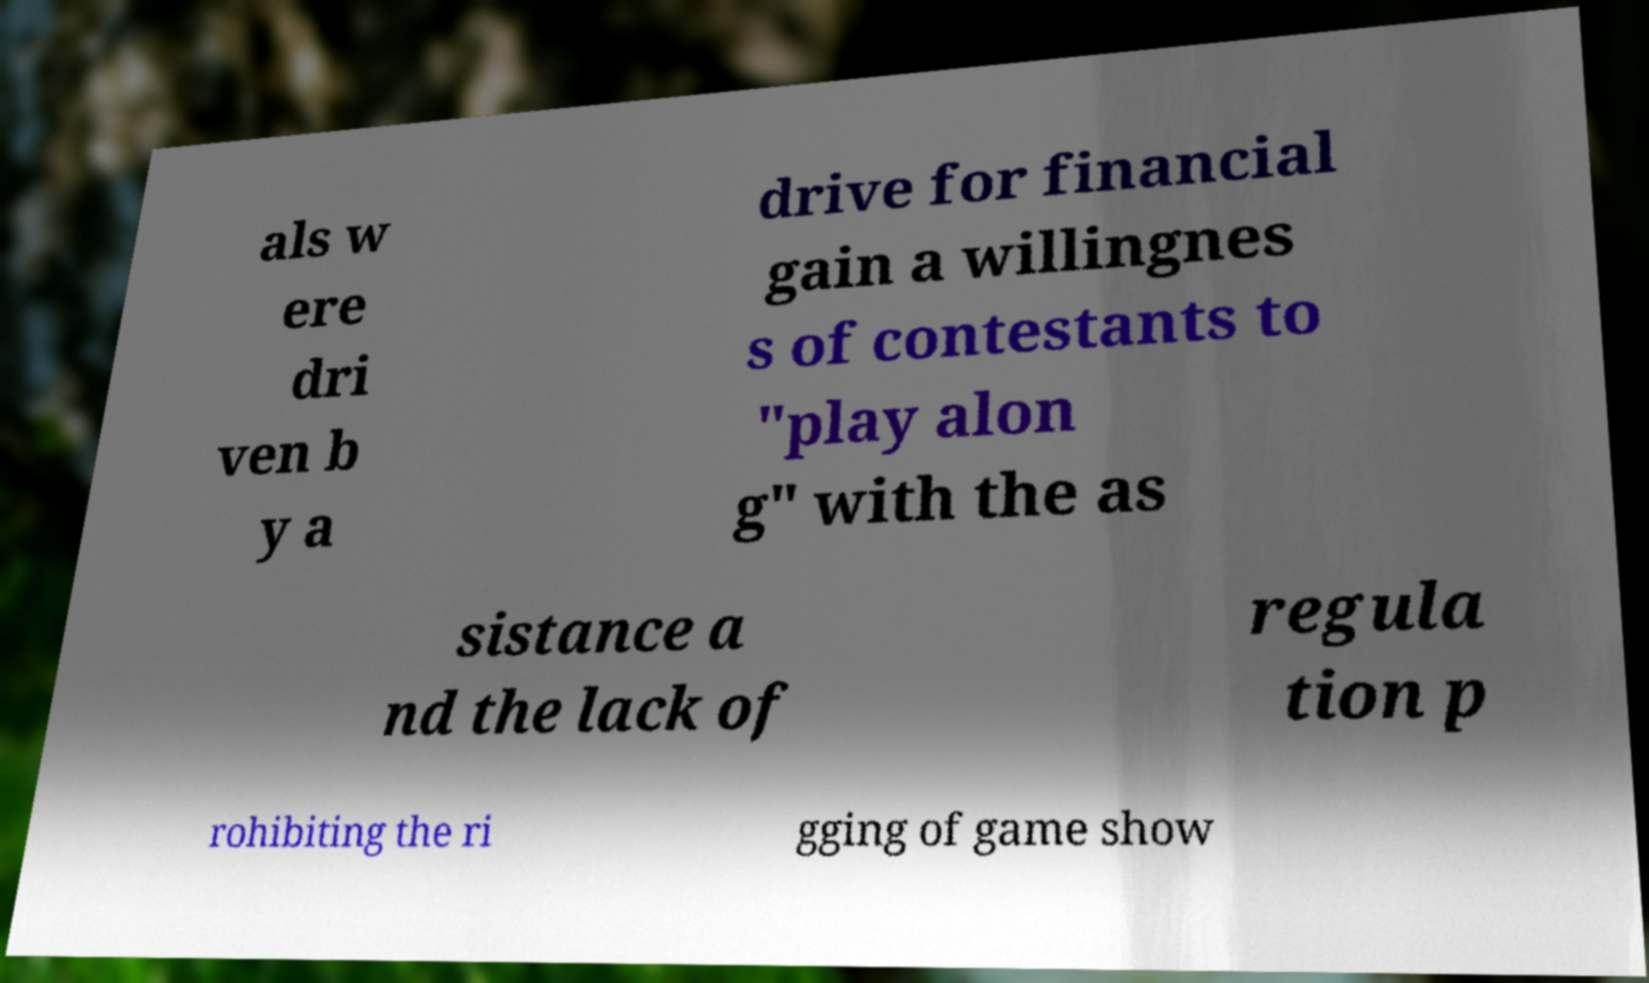Please identify and transcribe the text found in this image. als w ere dri ven b y a drive for financial gain a willingnes s of contestants to "play alon g" with the as sistance a nd the lack of regula tion p rohibiting the ri gging of game show 